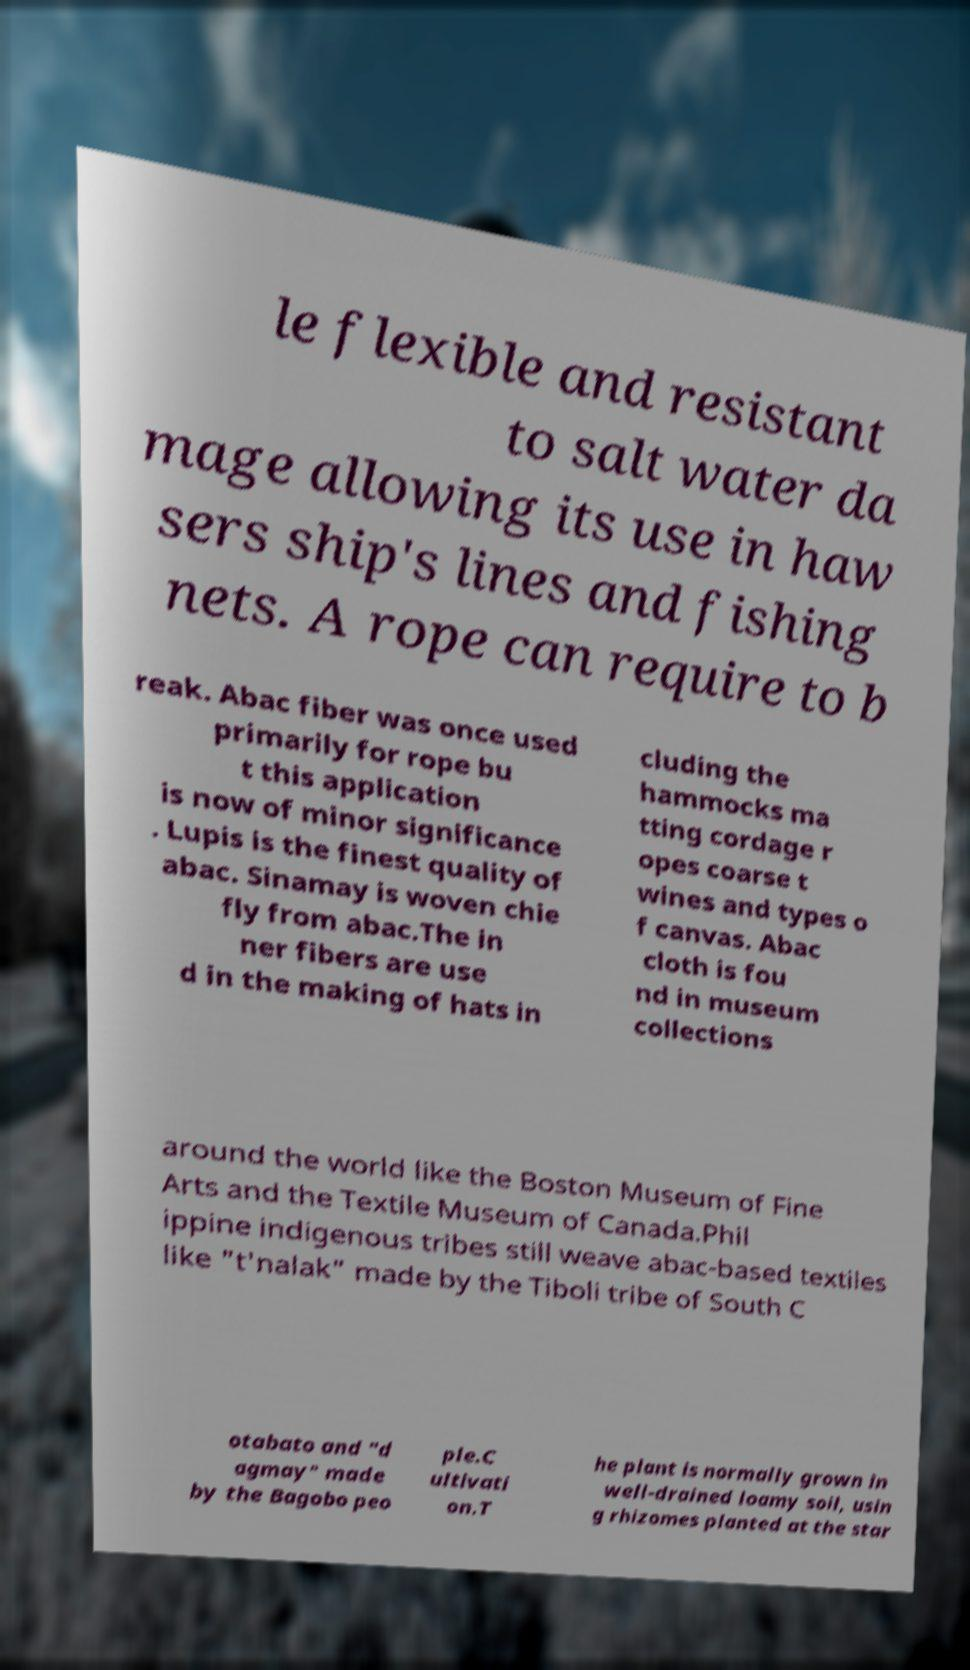Can you accurately transcribe the text from the provided image for me? le flexible and resistant to salt water da mage allowing its use in haw sers ship's lines and fishing nets. A rope can require to b reak. Abac fiber was once used primarily for rope bu t this application is now of minor significance . Lupis is the finest quality of abac. Sinamay is woven chie fly from abac.The in ner fibers are use d in the making of hats in cluding the hammocks ma tting cordage r opes coarse t wines and types o f canvas. Abac cloth is fou nd in museum collections around the world like the Boston Museum of Fine Arts and the Textile Museum of Canada.Phil ippine indigenous tribes still weave abac-based textiles like "t'nalak" made by the Tiboli tribe of South C otabato and "d agmay" made by the Bagobo peo ple.C ultivati on.T he plant is normally grown in well-drained loamy soil, usin g rhizomes planted at the star 